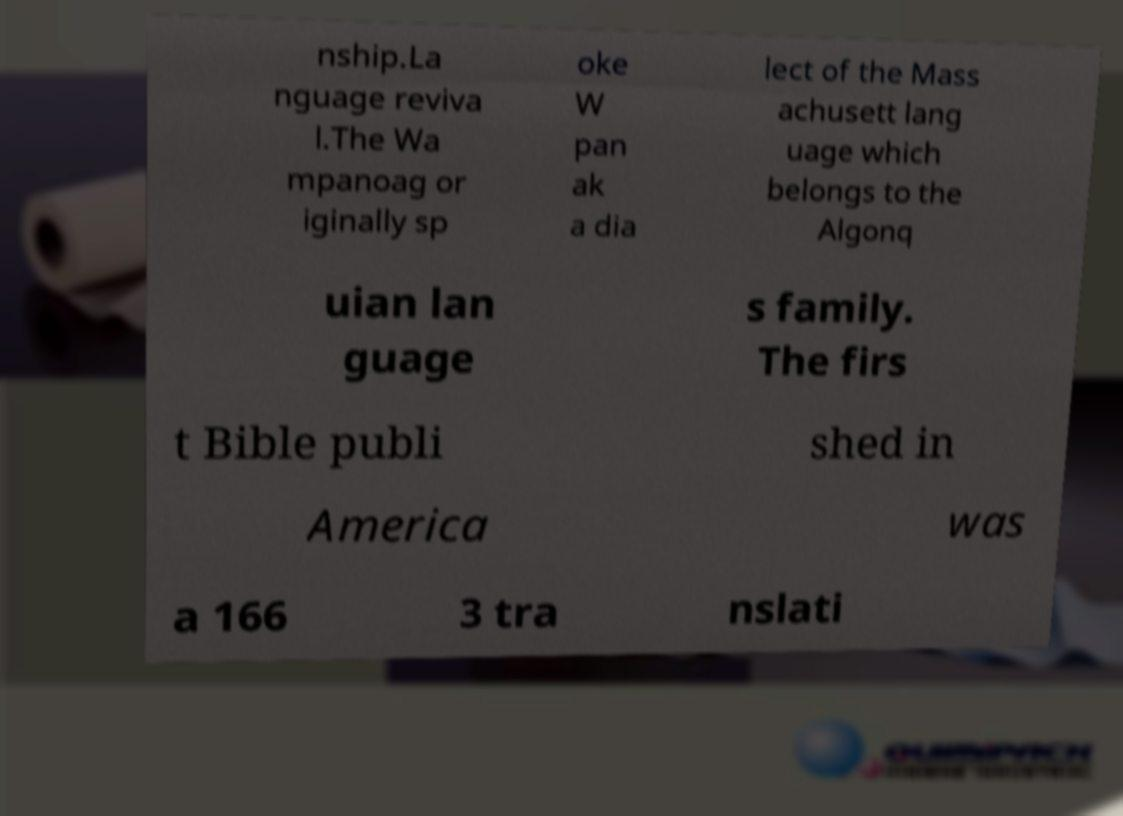Can you accurately transcribe the text from the provided image for me? nship.La nguage reviva l.The Wa mpanoag or iginally sp oke W pan ak a dia lect of the Mass achusett lang uage which belongs to the Algonq uian lan guage s family. The firs t Bible publi shed in America was a 166 3 tra nslati 